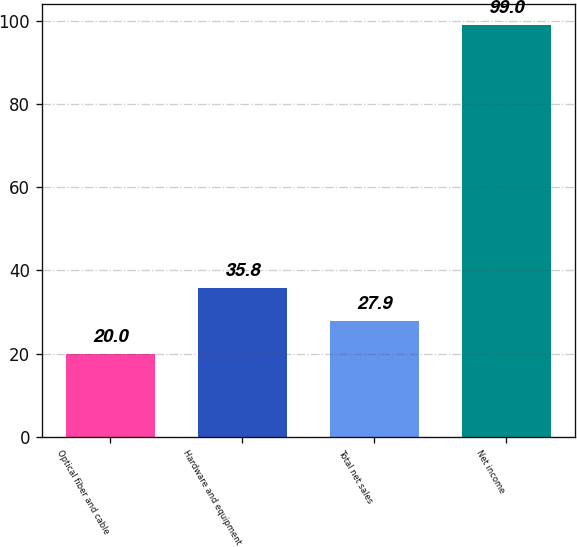Convert chart to OTSL. <chart><loc_0><loc_0><loc_500><loc_500><bar_chart><fcel>Optical fiber and cable<fcel>Hardware and equipment<fcel>Total net sales<fcel>Net income<nl><fcel>20<fcel>35.8<fcel>27.9<fcel>99<nl></chart> 